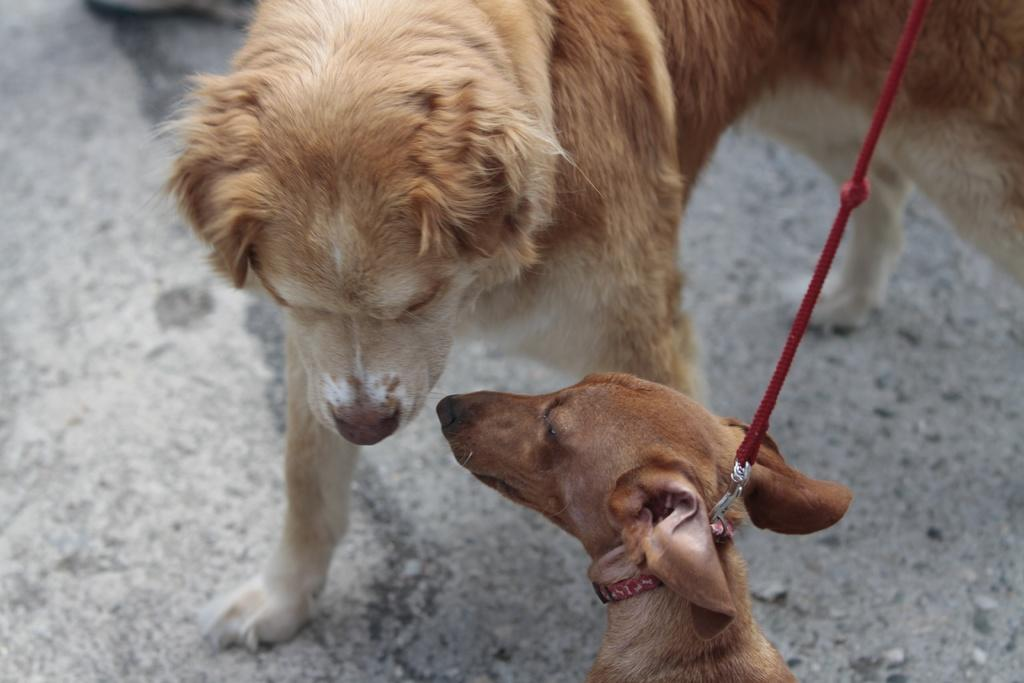What is the color of the dog's belt in the image? The dog's belt in the image is red. How is the belt connected to the dog? The belt is connected to the dog through a red color thread. What is the position of the other dog in the image? The other dog is standing on the road. Can you describe the relationship between the two dogs in the image? The dog with the red color belt is standing in front of the other dog. What type of bomb can be seen in the image? There is no bomb present in the image; it features two dogs, one with a red color belt. 